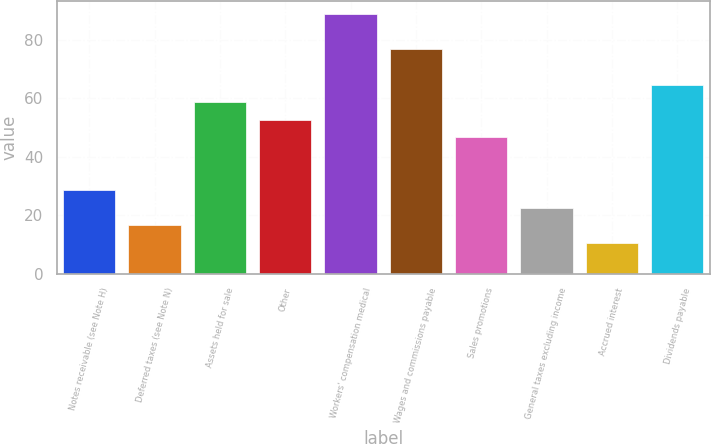Convert chart to OTSL. <chart><loc_0><loc_0><loc_500><loc_500><bar_chart><fcel>Notes receivable (see Note H)<fcel>Deferred taxes (see Note N)<fcel>Assets held for sale<fcel>Other<fcel>Workers' compensation medical<fcel>Wages and commissions payable<fcel>Sales promotions<fcel>General taxes excluding income<fcel>Accrued interest<fcel>Dividends payable<nl><fcel>28.56<fcel>16.52<fcel>58.66<fcel>52.64<fcel>88.76<fcel>76.72<fcel>46.62<fcel>22.54<fcel>10.5<fcel>64.68<nl></chart> 